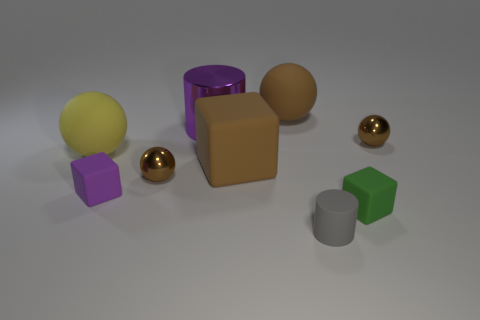Subtract all brown spheres. How many were subtracted if there are1brown spheres left? 2 Subtract all brown cubes. How many brown spheres are left? 3 Subtract all cylinders. How many objects are left? 7 Add 5 tiny purple blocks. How many tiny purple blocks are left? 6 Add 9 purple cubes. How many purple cubes exist? 10 Subtract 3 brown spheres. How many objects are left? 6 Subtract all tiny blocks. Subtract all purple cylinders. How many objects are left? 6 